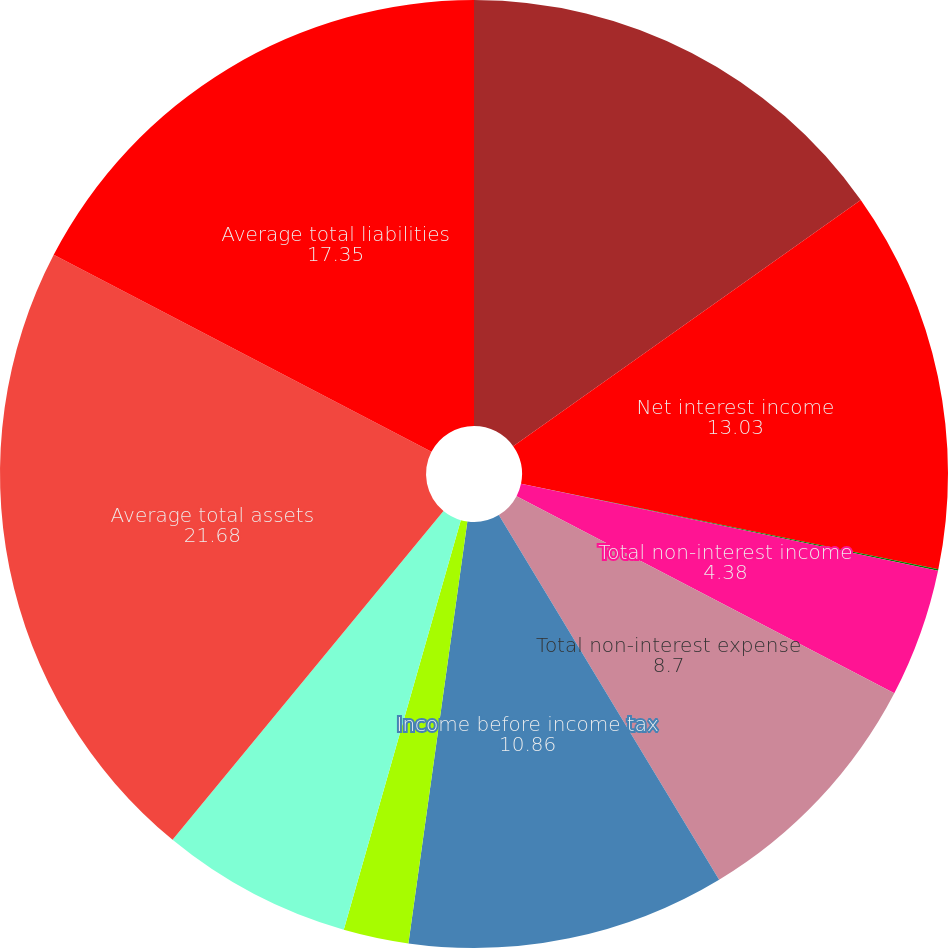Convert chart. <chart><loc_0><loc_0><loc_500><loc_500><pie_chart><fcel>Years ended December 31 (in<fcel>Net interest income<fcel>Provision for loan losses<fcel>Total non-interest income<fcel>Total non-interest expense<fcel>Income before income tax<fcel>Income tax expense<fcel>Net income<fcel>Average total assets<fcel>Average total liabilities<nl><fcel>15.19%<fcel>13.03%<fcel>0.05%<fcel>4.38%<fcel>8.7%<fcel>10.86%<fcel>2.22%<fcel>6.54%<fcel>21.68%<fcel>17.35%<nl></chart> 